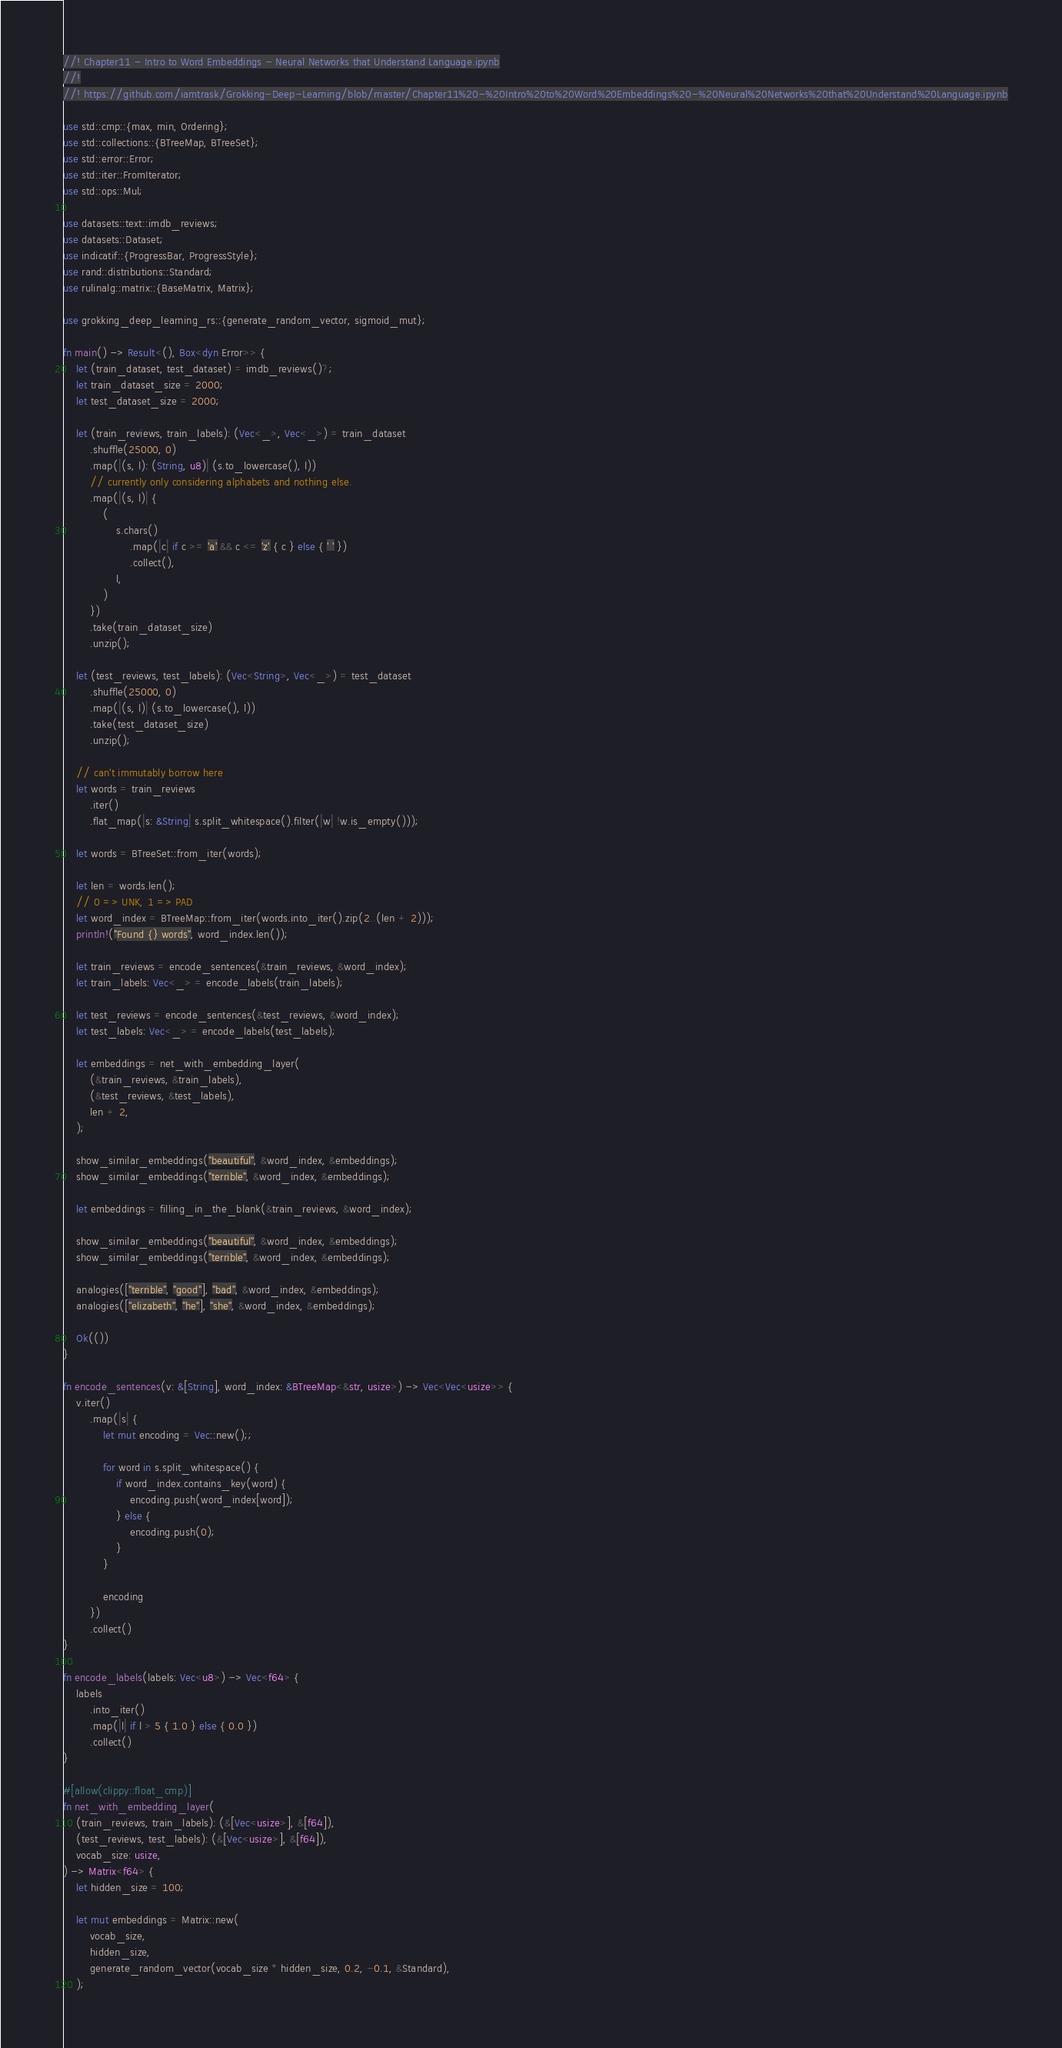Convert code to text. <code><loc_0><loc_0><loc_500><loc_500><_Rust_>//! Chapter11 - Intro to Word Embeddings - Neural Networks that Understand Language.ipynb
//!
//! https://github.com/iamtrask/Grokking-Deep-Learning/blob/master/Chapter11%20-%20Intro%20to%20Word%20Embeddings%20-%20Neural%20Networks%20that%20Understand%20Language.ipynb

use std::cmp::{max, min, Ordering};
use std::collections::{BTreeMap, BTreeSet};
use std::error::Error;
use std::iter::FromIterator;
use std::ops::Mul;

use datasets::text::imdb_reviews;
use datasets::Dataset;
use indicatif::{ProgressBar, ProgressStyle};
use rand::distributions::Standard;
use rulinalg::matrix::{BaseMatrix, Matrix};

use grokking_deep_learning_rs::{generate_random_vector, sigmoid_mut};

fn main() -> Result<(), Box<dyn Error>> {
    let (train_dataset, test_dataset) = imdb_reviews()?;
    let train_dataset_size = 2000;
    let test_dataset_size = 2000;

    let (train_reviews, train_labels): (Vec<_>, Vec<_>) = train_dataset
        .shuffle(25000, 0)
        .map(|(s, l): (String, u8)| (s.to_lowercase(), l))
        // currently only considering alphabets and nothing else.
        .map(|(s, l)| {
            (
                s.chars()
                    .map(|c| if c >= 'a' && c <= 'z' { c } else { ' ' })
                    .collect(),
                l,
            )
        })
        .take(train_dataset_size)
        .unzip();

    let (test_reviews, test_labels): (Vec<String>, Vec<_>) = test_dataset
        .shuffle(25000, 0)
        .map(|(s, l)| (s.to_lowercase(), l))
        .take(test_dataset_size)
        .unzip();

    // can't immutably borrow here
    let words = train_reviews
        .iter()
        .flat_map(|s: &String| s.split_whitespace().filter(|w| !w.is_empty()));

    let words = BTreeSet::from_iter(words);

    let len = words.len();
    // 0 => UNK, 1 => PAD
    let word_index = BTreeMap::from_iter(words.into_iter().zip(2..(len + 2)));
    println!("Found {} words", word_index.len());

    let train_reviews = encode_sentences(&train_reviews, &word_index);
    let train_labels: Vec<_> = encode_labels(train_labels);

    let test_reviews = encode_sentences(&test_reviews, &word_index);
    let test_labels: Vec<_> = encode_labels(test_labels);

    let embeddings = net_with_embedding_layer(
        (&train_reviews, &train_labels),
        (&test_reviews, &test_labels),
        len + 2,
    );

    show_similar_embeddings("beautiful", &word_index, &embeddings);
    show_similar_embeddings("terrible", &word_index, &embeddings);

    let embeddings = filling_in_the_blank(&train_reviews, &word_index);

    show_similar_embeddings("beautiful", &word_index, &embeddings);
    show_similar_embeddings("terrible", &word_index, &embeddings);

    analogies(["terrible", "good"], "bad", &word_index, &embeddings);
    analogies(["elizabeth", "he"], "she", &word_index, &embeddings);

    Ok(())
}

fn encode_sentences(v: &[String], word_index: &BTreeMap<&str, usize>) -> Vec<Vec<usize>> {
    v.iter()
        .map(|s| {
            let mut encoding = Vec::new();;

            for word in s.split_whitespace() {
                if word_index.contains_key(word) {
                    encoding.push(word_index[word]);
                } else {
                    encoding.push(0);
                }
            }

            encoding
        })
        .collect()
}

fn encode_labels(labels: Vec<u8>) -> Vec<f64> {
    labels
        .into_iter()
        .map(|l| if l > 5 { 1.0 } else { 0.0 })
        .collect()
}

#[allow(clippy::float_cmp)]
fn net_with_embedding_layer(
    (train_reviews, train_labels): (&[Vec<usize>], &[f64]),
    (test_reviews, test_labels): (&[Vec<usize>], &[f64]),
    vocab_size: usize,
) -> Matrix<f64> {
    let hidden_size = 100;

    let mut embeddings = Matrix::new(
        vocab_size,
        hidden_size,
        generate_random_vector(vocab_size * hidden_size, 0.2, -0.1, &Standard),
    );
</code> 